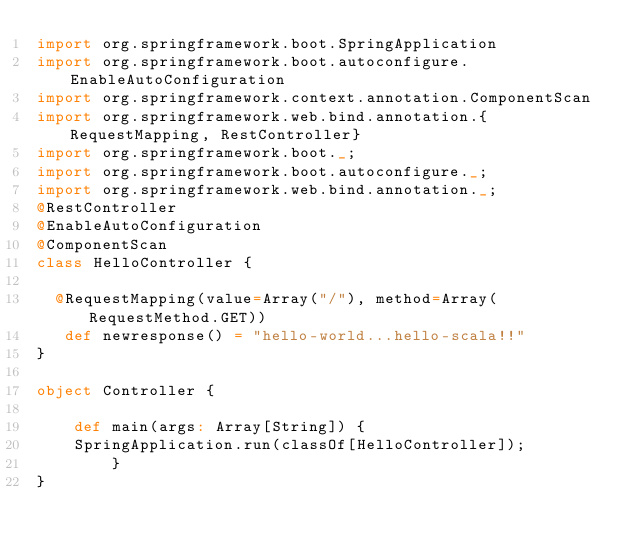Convert code to text. <code><loc_0><loc_0><loc_500><loc_500><_Scala_>import org.springframework.boot.SpringApplication
import org.springframework.boot.autoconfigure.EnableAutoConfiguration
import org.springframework.context.annotation.ComponentScan
import org.springframework.web.bind.annotation.{RequestMapping, RestController}
import org.springframework.boot._;
import org.springframework.boot.autoconfigure._;
import org.springframework.web.bind.annotation._;
@RestController
@EnableAutoConfiguration
@ComponentScan
class HelloController {

  @RequestMapping(value=Array("/"), method=Array(RequestMethod.GET))
   def newresponse() = "hello-world...hello-scala!!"
}

object Controller {

    def main(args: Array[String]) {
    SpringApplication.run(classOf[HelloController]);
        }
}
 
</code> 